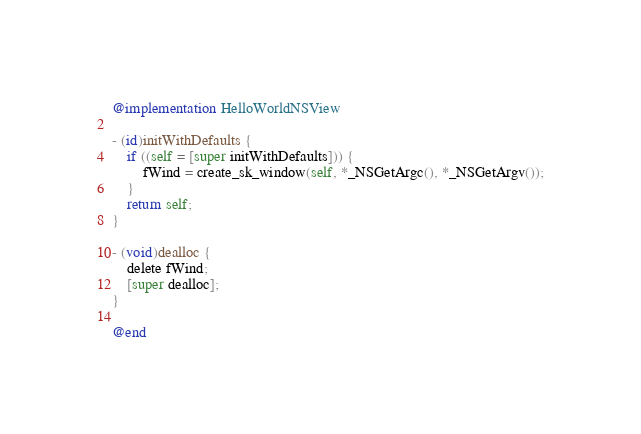Convert code to text. <code><loc_0><loc_0><loc_500><loc_500><_ObjectiveC_>@implementation HelloWorldNSView

- (id)initWithDefaults {
    if ((self = [super initWithDefaults])) {
        fWind = create_sk_window(self, *_NSGetArgc(), *_NSGetArgv());
    }
    return self;
}

- (void)dealloc {
    delete fWind;
    [super dealloc];
}

@end
</code> 